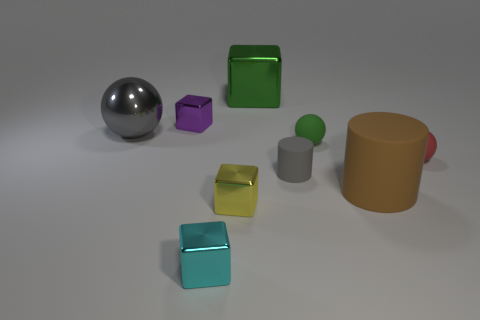There is a large sphere that is the same color as the small rubber cylinder; what is its material?
Ensure brevity in your answer.  Metal. Are there any large objects that have the same color as the small cylinder?
Make the answer very short. Yes. Does the sphere behind the tiny green object have the same color as the small rubber cylinder?
Your answer should be very brief. Yes. What number of objects are tiny metallic cubes that are in front of the brown rubber cylinder or brown rubber objects?
Your response must be concise. 3. Are there more yellow cubes that are in front of the large ball than gray metallic objects that are behind the large cylinder?
Make the answer very short. No. Is the purple object made of the same material as the small cylinder?
Provide a short and direct response. No. There is a shiny object that is on the right side of the cyan metal object and in front of the big brown object; what is its shape?
Provide a succinct answer. Cube. What is the shape of the large gray thing that is made of the same material as the tiny cyan block?
Your response must be concise. Sphere. Is there a tiny purple block?
Give a very brief answer. Yes. There is a gray object to the left of the gray matte cylinder; is there a big brown object that is right of it?
Offer a very short reply. Yes. 